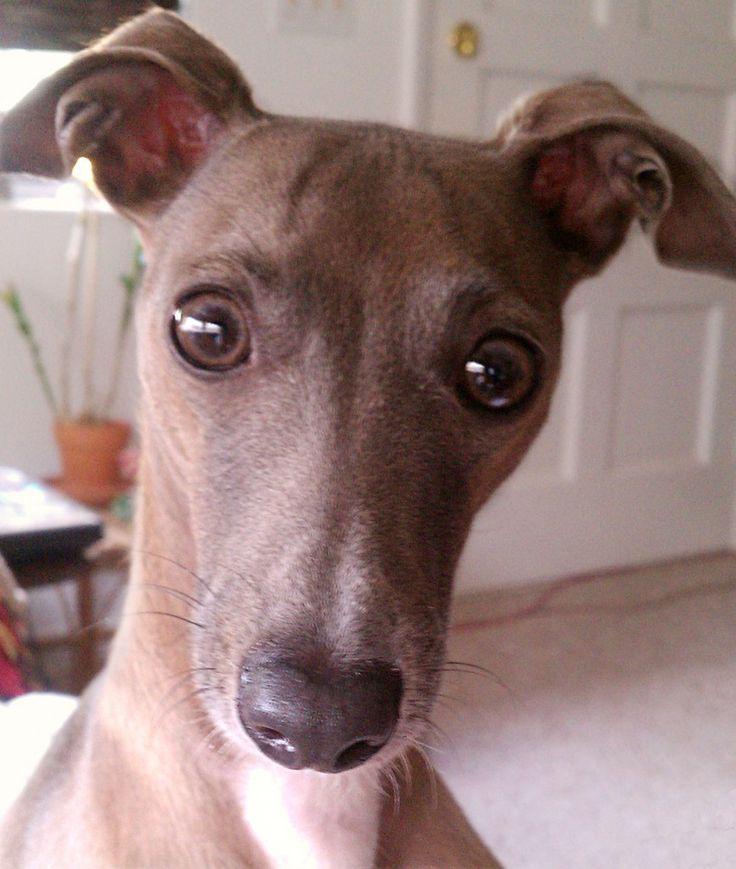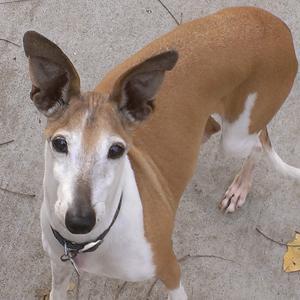The first image is the image on the left, the second image is the image on the right. Considering the images on both sides, is "There is a collar around the neck of at least one dog in the image on the right." valid? Answer yes or no. Yes. The first image is the image on the left, the second image is the image on the right. For the images displayed, is the sentence "The combined images include a hound wearing a pink collar and the images include an item of apparel worn by a dog that is not a collar." factually correct? Answer yes or no. No. 